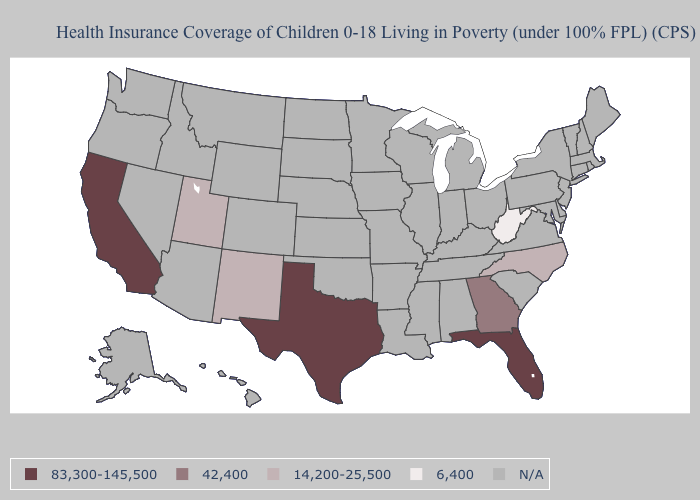Name the states that have a value in the range 42,400?
Give a very brief answer. Georgia. Which states hav the highest value in the West?
Answer briefly. California. Is the legend a continuous bar?
Concise answer only. No. Name the states that have a value in the range 42,400?
Keep it brief. Georgia. Does the map have missing data?
Be succinct. Yes. Name the states that have a value in the range 14,200-25,500?
Concise answer only. New Mexico, North Carolina, Utah. Name the states that have a value in the range 83,300-145,500?
Write a very short answer. California, Florida, Texas. What is the value of Wyoming?
Write a very short answer. N/A. Does West Virginia have the lowest value in the USA?
Quick response, please. Yes. Name the states that have a value in the range 83,300-145,500?
Answer briefly. California, Florida, Texas. Which states have the lowest value in the USA?
Short answer required. West Virginia. What is the highest value in the West ?
Keep it brief. 83,300-145,500. 